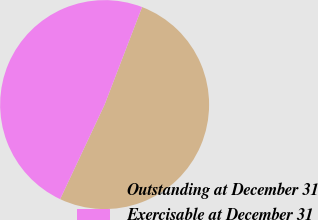Convert chart to OTSL. <chart><loc_0><loc_0><loc_500><loc_500><pie_chart><fcel>Outstanding at December 31<fcel>Exercisable at December 31<nl><fcel>51.16%<fcel>48.84%<nl></chart> 